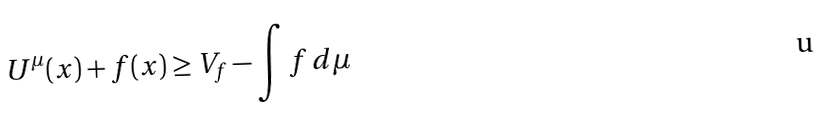<formula> <loc_0><loc_0><loc_500><loc_500>U ^ { \mu } ( x ) + f ( x ) \geq V _ { f } - \int f \, d \mu</formula> 